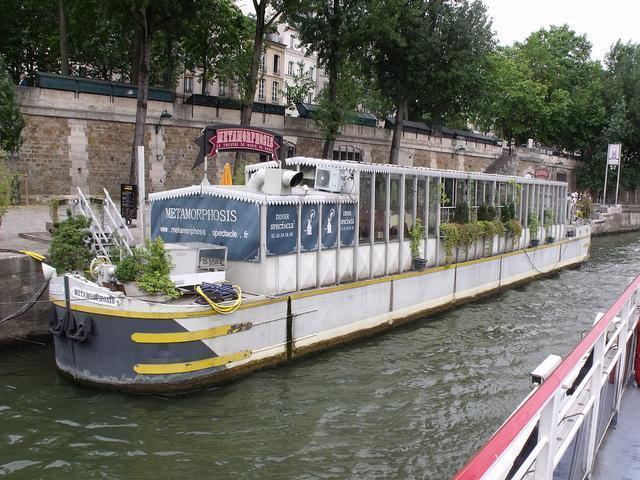Who wrote a book whose title matches the word at the front top of the boat?
Choose the right answer and clarify with the format: 'Answer: answer
Rationale: rationale.'
Options: Joe hill, franz kafka, jack ryan, jim sturgess. Answer: franz kafka.
Rationale: He had a book with that word in the title and is known for that work that he did. 